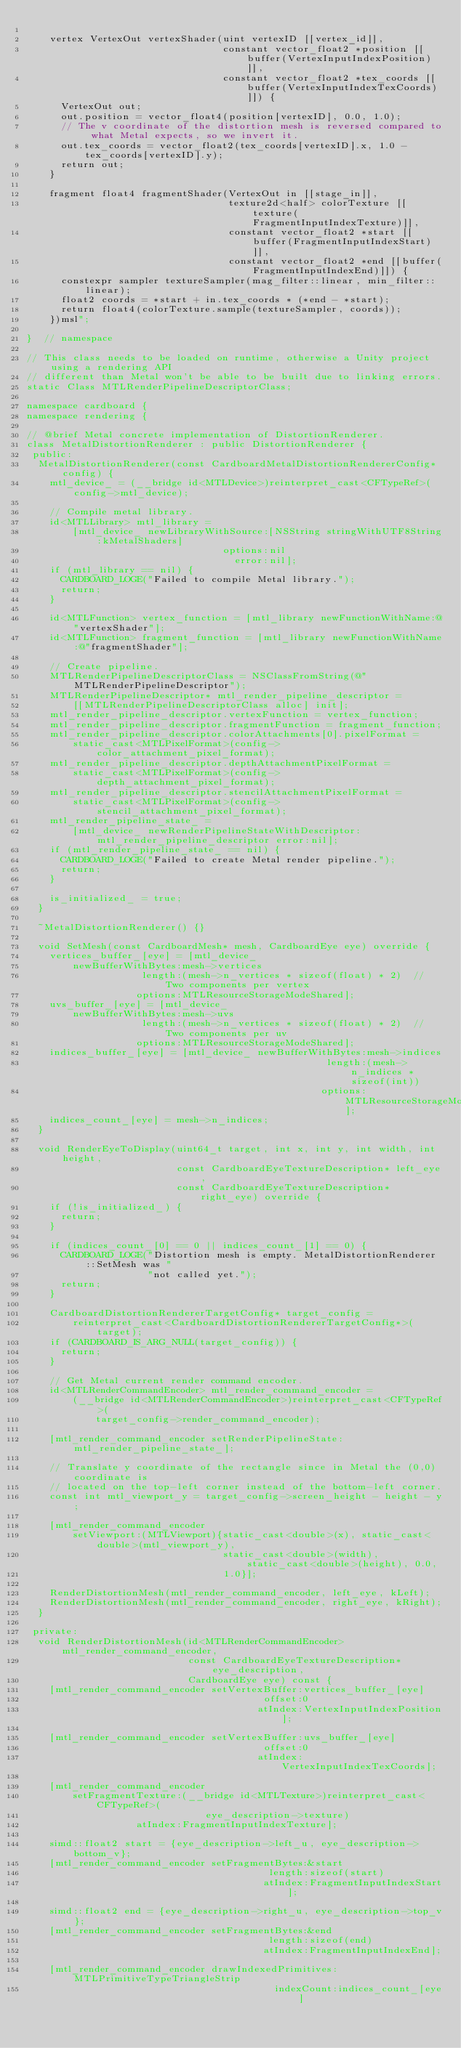<code> <loc_0><loc_0><loc_500><loc_500><_ObjectiveC_>
    vertex VertexOut vertexShader(uint vertexID [[vertex_id]],
                                  constant vector_float2 *position [[buffer(VertexInputIndexPosition)]],
                                  constant vector_float2 *tex_coords [[buffer(VertexInputIndexTexCoords)]]) {
      VertexOut out;
      out.position = vector_float4(position[vertexID], 0.0, 1.0);
      // The v coordinate of the distortion mesh is reversed compared to what Metal expects, so we invert it.
      out.tex_coords = vector_float2(tex_coords[vertexID].x, 1.0 - tex_coords[vertexID].y);
      return out;
    }

    fragment float4 fragmentShader(VertexOut in [[stage_in]],
                                   texture2d<half> colorTexture [[texture(FragmentInputIndexTexture)]],
                                   constant vector_float2 *start [[buffer(FragmentInputIndexStart)]],
                                   constant vector_float2 *end [[buffer(FragmentInputIndexEnd)]]) {
      constexpr sampler textureSampler(mag_filter::linear, min_filter::linear);
      float2 coords = *start + in.tex_coords * (*end - *start);
      return float4(colorTexture.sample(textureSampler, coords));
    })msl";

}  // namespace

// This class needs to be loaded on runtime, otherwise a Unity project using a rendering API
// different than Metal won't be able to be built due to linking errors.
static Class MTLRenderPipelineDescriptorClass;

namespace cardboard {
namespace rendering {

// @brief Metal concrete implementation of DistortionRenderer.
class MetalDistortionRenderer : public DistortionRenderer {
 public:
  MetalDistortionRenderer(const CardboardMetalDistortionRendererConfig* config) {
    mtl_device_ = (__bridge id<MTLDevice>)reinterpret_cast<CFTypeRef>(config->mtl_device);

    // Compile metal library.
    id<MTLLibrary> mtl_library =
        [mtl_device_ newLibraryWithSource:[NSString stringWithUTF8String:kMetalShaders]
                                  options:nil
                                    error:nil];
    if (mtl_library == nil) {
      CARDBOARD_LOGE("Failed to compile Metal library.");
      return;
    }

    id<MTLFunction> vertex_function = [mtl_library newFunctionWithName:@"vertexShader"];
    id<MTLFunction> fragment_function = [mtl_library newFunctionWithName:@"fragmentShader"];

    // Create pipeline.
    MTLRenderPipelineDescriptorClass = NSClassFromString(@"MTLRenderPipelineDescriptor");
    MTLRenderPipelineDescriptor* mtl_render_pipeline_descriptor =
        [[MTLRenderPipelineDescriptorClass alloc] init];
    mtl_render_pipeline_descriptor.vertexFunction = vertex_function;
    mtl_render_pipeline_descriptor.fragmentFunction = fragment_function;
    mtl_render_pipeline_descriptor.colorAttachments[0].pixelFormat =
        static_cast<MTLPixelFormat>(config->color_attachment_pixel_format);
    mtl_render_pipeline_descriptor.depthAttachmentPixelFormat =
        static_cast<MTLPixelFormat>(config->depth_attachment_pixel_format);
    mtl_render_pipeline_descriptor.stencilAttachmentPixelFormat =
        static_cast<MTLPixelFormat>(config->stencil_attachment_pixel_format);
    mtl_render_pipeline_state_ =
        [mtl_device_ newRenderPipelineStateWithDescriptor:mtl_render_pipeline_descriptor error:nil];
    if (mtl_render_pipeline_state_ == nil) {
      CARDBOARD_LOGE("Failed to create Metal render pipeline.");
      return;
    }

    is_initialized_ = true;
  }

  ~MetalDistortionRenderer() {}

  void SetMesh(const CardboardMesh* mesh, CardboardEye eye) override {
    vertices_buffer_[eye] = [mtl_device_
        newBufferWithBytes:mesh->vertices
                    length:(mesh->n_vertices * sizeof(float) * 2)  // Two components per vertex
                   options:MTLResourceStorageModeShared];
    uvs_buffer_[eye] = [mtl_device_
        newBufferWithBytes:mesh->uvs
                    length:(mesh->n_vertices * sizeof(float) * 2)  // Two components per uv
                   options:MTLResourceStorageModeShared];
    indices_buffer_[eye] = [mtl_device_ newBufferWithBytes:mesh->indices
                                                    length:(mesh->n_indices * sizeof(int))
                                                   options:MTLResourceStorageModeShared];
    indices_count_[eye] = mesh->n_indices;
  }

  void RenderEyeToDisplay(uint64_t target, int x, int y, int width, int height,
                          const CardboardEyeTextureDescription* left_eye,
                          const CardboardEyeTextureDescription* right_eye) override {
    if (!is_initialized_) {
      return;
    }

    if (indices_count_[0] == 0 || indices_count_[1] == 0) {
      CARDBOARD_LOGE("Distortion mesh is empty. MetalDistortionRenderer::SetMesh was "
                     "not called yet.");
      return;
    }

    CardboardDistortionRendererTargetConfig* target_config =
        reinterpret_cast<CardboardDistortionRendererTargetConfig*>(target);
    if (CARDBOARD_IS_ARG_NULL(target_config)) {
      return;
    }

    // Get Metal current render command encoder.
    id<MTLRenderCommandEncoder> mtl_render_command_encoder =
        (__bridge id<MTLRenderCommandEncoder>)reinterpret_cast<CFTypeRef>(
            target_config->render_command_encoder);

    [mtl_render_command_encoder setRenderPipelineState:mtl_render_pipeline_state_];

    // Translate y coordinate of the rectangle since in Metal the (0,0) coordinate is
    // located on the top-left corner instead of the bottom-left corner.
    const int mtl_viewport_y = target_config->screen_height - height - y;

    [mtl_render_command_encoder
        setViewport:(MTLViewport){static_cast<double>(x), static_cast<double>(mtl_viewport_y),
                                  static_cast<double>(width), static_cast<double>(height), 0.0,
                                  1.0}];

    RenderDistortionMesh(mtl_render_command_encoder, left_eye, kLeft);
    RenderDistortionMesh(mtl_render_command_encoder, right_eye, kRight);
  }

 private:
  void RenderDistortionMesh(id<MTLRenderCommandEncoder> mtl_render_command_encoder,
                            const CardboardEyeTextureDescription* eye_description,
                            CardboardEye eye) const {
    [mtl_render_command_encoder setVertexBuffer:vertices_buffer_[eye]
                                         offset:0
                                        atIndex:VertexInputIndexPosition];

    [mtl_render_command_encoder setVertexBuffer:uvs_buffer_[eye]
                                         offset:0
                                        atIndex:VertexInputIndexTexCoords];

    [mtl_render_command_encoder
        setFragmentTexture:(__bridge id<MTLTexture>)reinterpret_cast<CFTypeRef>(
                               eye_description->texture)
                   atIndex:FragmentInputIndexTexture];

    simd::float2 start = {eye_description->left_u, eye_description->bottom_v};
    [mtl_render_command_encoder setFragmentBytes:&start
                                          length:sizeof(start)
                                         atIndex:FragmentInputIndexStart];

    simd::float2 end = {eye_description->right_u, eye_description->top_v};
    [mtl_render_command_encoder setFragmentBytes:&end
                                          length:sizeof(end)
                                         atIndex:FragmentInputIndexEnd];

    [mtl_render_command_encoder drawIndexedPrimitives:MTLPrimitiveTypeTriangleStrip
                                           indexCount:indices_count_[eye]</code> 